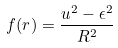Convert formula to latex. <formula><loc_0><loc_0><loc_500><loc_500>f ( r ) = \frac { u ^ { 2 } - \epsilon ^ { 2 } } { R ^ { 2 } }</formula> 